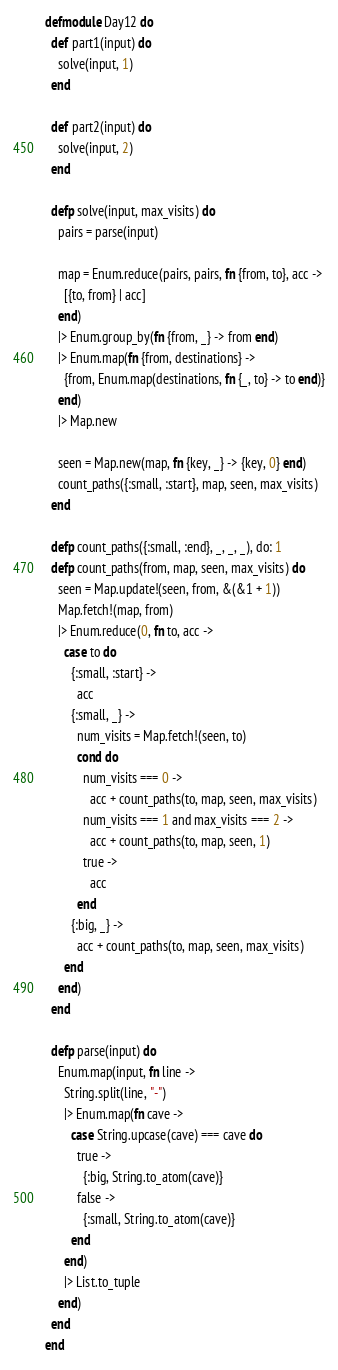Convert code to text. <code><loc_0><loc_0><loc_500><loc_500><_Elixir_>defmodule Day12 do
  def part1(input) do
    solve(input, 1)
  end

  def part2(input) do
    solve(input, 2)
  end

  defp solve(input, max_visits) do
    pairs = parse(input)

    map = Enum.reduce(pairs, pairs, fn {from, to}, acc ->
      [{to, from} | acc]
    end)
    |> Enum.group_by(fn {from, _} -> from end)
    |> Enum.map(fn {from, destinations} ->
      {from, Enum.map(destinations, fn {_, to} -> to end)}
    end)
    |> Map.new

    seen = Map.new(map, fn {key, _} -> {key, 0} end)
    count_paths({:small, :start}, map, seen, max_visits)
  end

  defp count_paths({:small, :end}, _, _, _), do: 1
  defp count_paths(from, map, seen, max_visits) do
    seen = Map.update!(seen, from, &(&1 + 1))
    Map.fetch!(map, from)
    |> Enum.reduce(0, fn to, acc ->
      case to do
        {:small, :start} ->
          acc
        {:small, _} ->
          num_visits = Map.fetch!(seen, to)
          cond do
            num_visits === 0 ->
              acc + count_paths(to, map, seen, max_visits)
            num_visits === 1 and max_visits === 2 ->
              acc + count_paths(to, map, seen, 1)
            true ->
              acc
          end
        {:big, _} ->
          acc + count_paths(to, map, seen, max_visits)
      end
    end)
  end

  defp parse(input) do
    Enum.map(input, fn line ->
      String.split(line, "-")
      |> Enum.map(fn cave ->
        case String.upcase(cave) === cave do
          true ->
            {:big, String.to_atom(cave)}
          false ->
            {:small, String.to_atom(cave)}
        end
      end)
      |> List.to_tuple
    end)
  end
end
</code> 